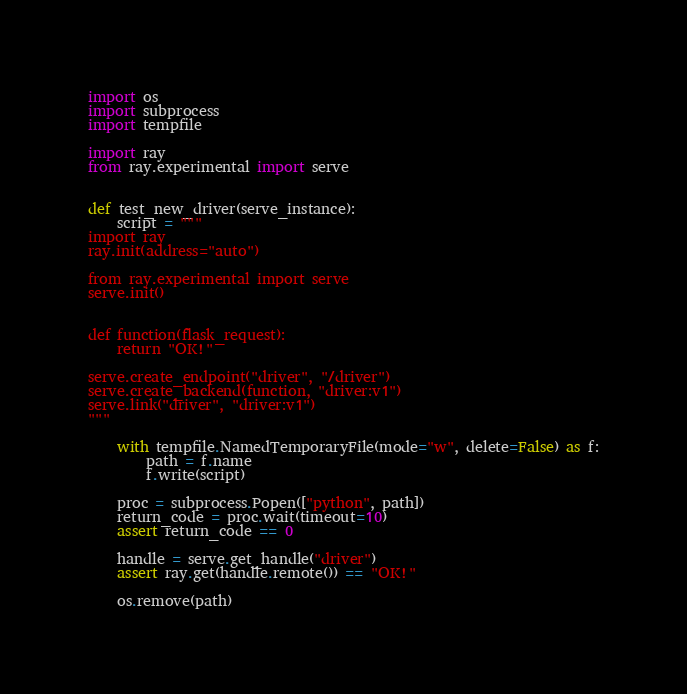<code> <loc_0><loc_0><loc_500><loc_500><_Python_>import os
import subprocess
import tempfile

import ray
from ray.experimental import serve


def test_new_driver(serve_instance):
    script = """
import ray
ray.init(address="auto")

from ray.experimental import serve
serve.init()


def function(flask_request):
    return "OK!"

serve.create_endpoint("driver", "/driver")
serve.create_backend(function, "driver:v1")
serve.link("driver", "driver:v1")
"""

    with tempfile.NamedTemporaryFile(mode="w", delete=False) as f:
        path = f.name
        f.write(script)

    proc = subprocess.Popen(["python", path])
    return_code = proc.wait(timeout=10)
    assert return_code == 0

    handle = serve.get_handle("driver")
    assert ray.get(handle.remote()) == "OK!"

    os.remove(path)
</code> 